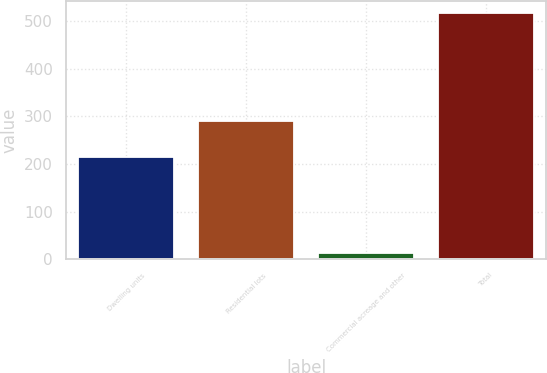Convert chart to OTSL. <chart><loc_0><loc_0><loc_500><loc_500><bar_chart><fcel>Dwelling units<fcel>Residential lots<fcel>Commercial acreage and other<fcel>Total<nl><fcel>215<fcel>289<fcel>13<fcel>517<nl></chart> 